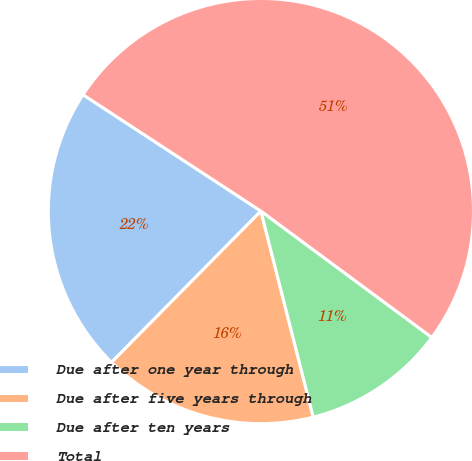<chart> <loc_0><loc_0><loc_500><loc_500><pie_chart><fcel>Due after one year through<fcel>Due after five years through<fcel>Due after ten years<fcel>Total<nl><fcel>21.82%<fcel>16.36%<fcel>10.91%<fcel>50.91%<nl></chart> 